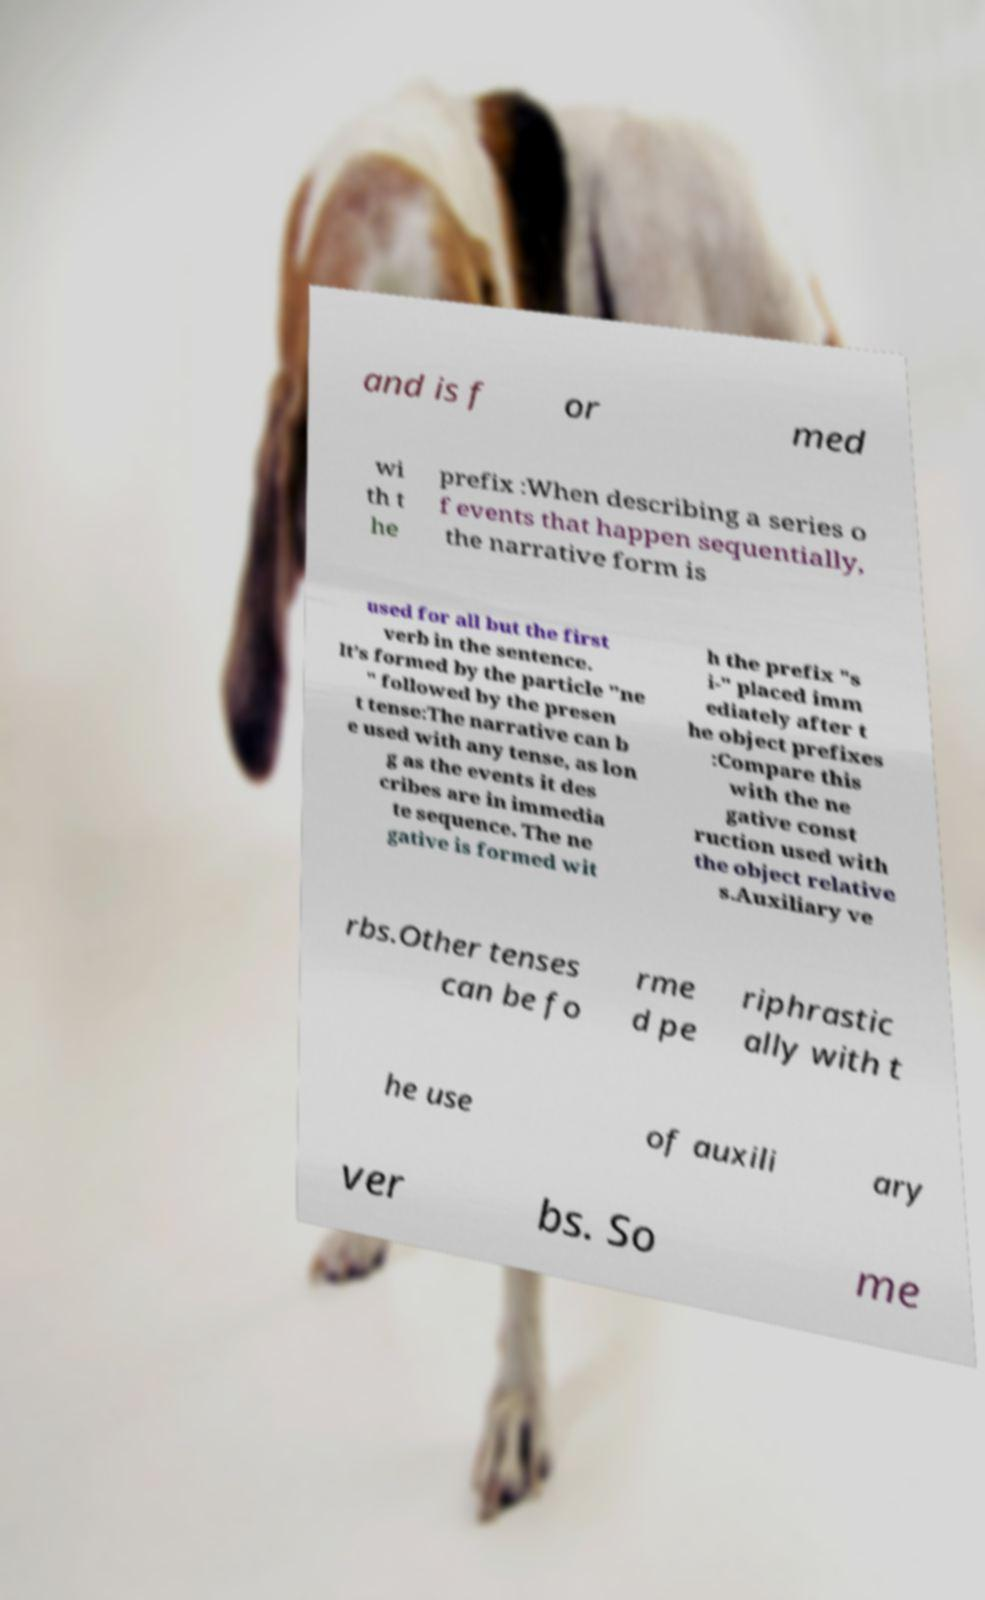Can you accurately transcribe the text from the provided image for me? and is f or med wi th t he prefix :When describing a series o f events that happen sequentially, the narrative form is used for all but the first verb in the sentence. It’s formed by the particle "ne " followed by the presen t tense:The narrative can b e used with any tense, as lon g as the events it des cribes are in immedia te sequence. The ne gative is formed wit h the prefix "s i-" placed imm ediately after t he object prefixes :Compare this with the ne gative const ruction used with the object relative s.Auxiliary ve rbs.Other tenses can be fo rme d pe riphrastic ally with t he use of auxili ary ver bs. So me 